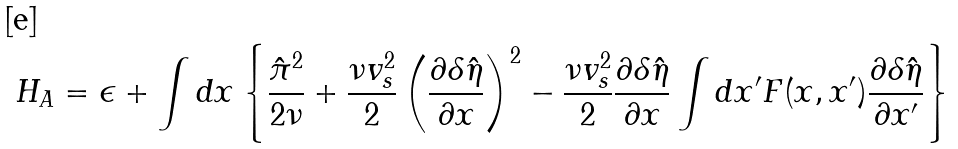Convert formula to latex. <formula><loc_0><loc_0><loc_500><loc_500>H _ { A } = \epsilon + \int { d x } \left \{ \frac { \hat { \pi } ^ { 2 } } { 2 \nu } + \frac { \nu v ^ { 2 } _ { s } } { 2 } \left ( \frac { \partial \delta \hat { \eta } } { \partial x } \right ) ^ { 2 } - \frac { \nu v ^ { 2 } _ { s } } { 2 } \frac { \partial \delta \hat { \eta } } { \partial x } \int { d x ^ { \prime } } F ( x , x ^ { \prime } ) \frac { \partial \delta \hat { \eta } } { \partial x ^ { \prime } } \right \}</formula> 